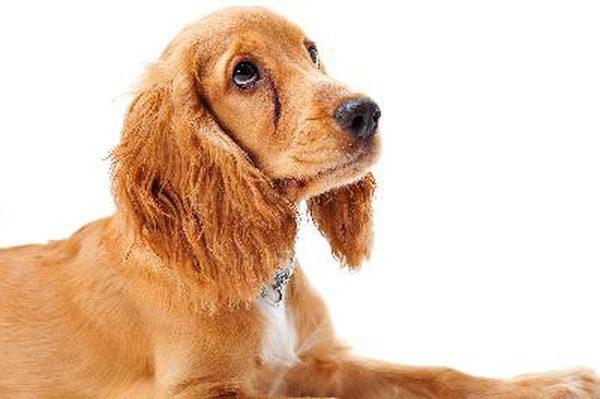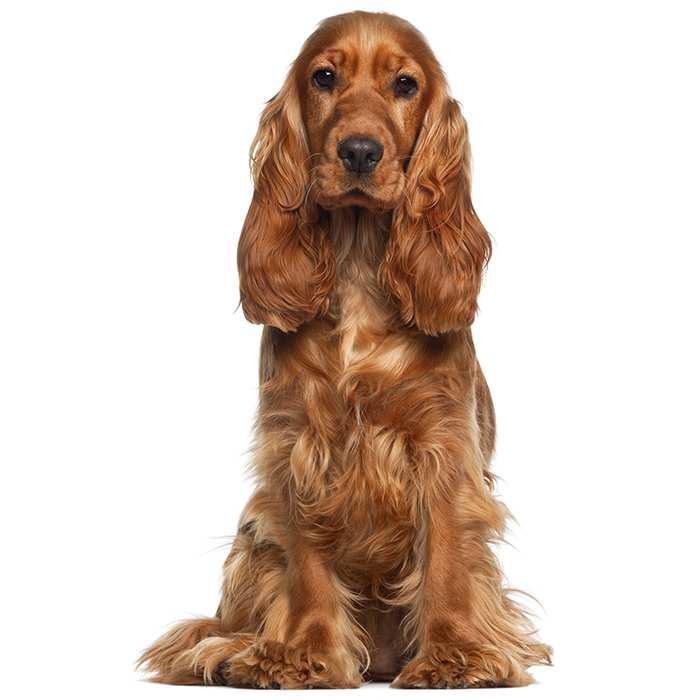The first image is the image on the left, the second image is the image on the right. Considering the images on both sides, is "A dog is standing on all fours in one of the images" valid? Answer yes or no. No. The first image is the image on the left, the second image is the image on the right. Given the left and right images, does the statement "There is at least one dog against a plain white background in the image on the left." hold true? Answer yes or no. Yes. 